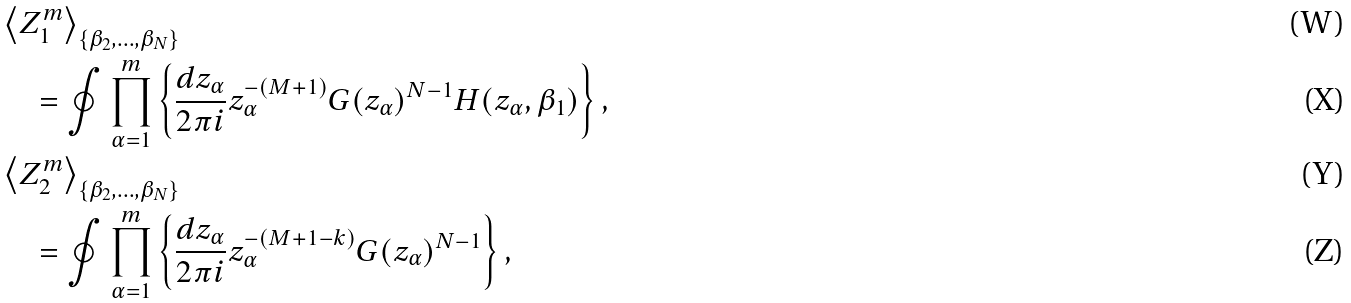<formula> <loc_0><loc_0><loc_500><loc_500>& \left \langle Z _ { 1 } ^ { m } \right \rangle _ { \{ \beta _ { 2 } , \dots , \beta _ { N } \} } \\ & \quad = \oint \prod _ { \alpha = 1 } ^ { m } \left \{ \frac { d z _ { \alpha } } { 2 \pi i } z _ { \alpha } ^ { - ( M + 1 ) } G ( z _ { \alpha } ) ^ { N - 1 } H ( z _ { \alpha } , \beta _ { 1 } ) \right \} , \\ & \left \langle Z _ { 2 } ^ { m } \right \rangle _ { \{ \beta _ { 2 } , \dots , \beta _ { N } \} } \\ & \quad = \oint \prod _ { \alpha = 1 } ^ { m } \left \{ \frac { d z _ { \alpha } } { 2 \pi i } z _ { \alpha } ^ { - ( M + 1 - k ) } G ( z _ { \alpha } ) ^ { N - 1 } \right \} ,</formula> 